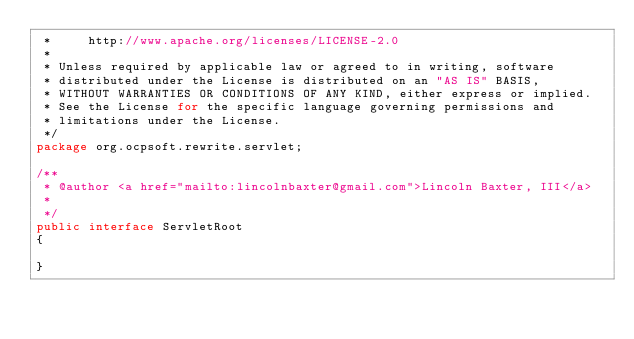Convert code to text. <code><loc_0><loc_0><loc_500><loc_500><_Java_> *     http://www.apache.org/licenses/LICENSE-2.0
 * 
 * Unless required by applicable law or agreed to in writing, software
 * distributed under the License is distributed on an "AS IS" BASIS,
 * WITHOUT WARRANTIES OR CONDITIONS OF ANY KIND, either express or implied.
 * See the License for the specific language governing permissions and
 * limitations under the License.
 */
package org.ocpsoft.rewrite.servlet;

/**
 * @author <a href="mailto:lincolnbaxter@gmail.com">Lincoln Baxter, III</a>
 *
 */
public interface ServletRoot
{

}
</code> 